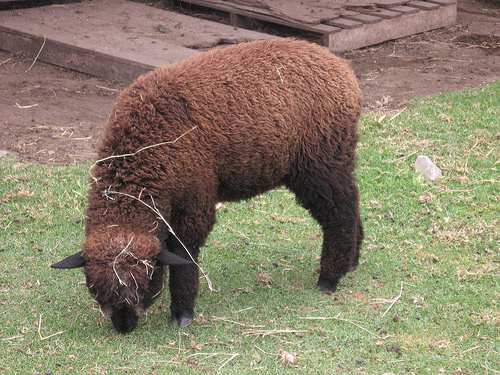Are the colors in the image natural?
A. Monochromatic
B. Artificial
C. Oversaturated
D. Yes. The colors in the image appear to be natural. The appearance of the animal and the surrounding environment do not show indications of artificial coloring or oversaturation. As it is a photograph of a real scene, it is not monochromatic either. Therefore, the most accurate answer among the given options would be to state that the colors are natural, but as this is not directly an option, none of the available choices A, B, or C are entirely correct. 